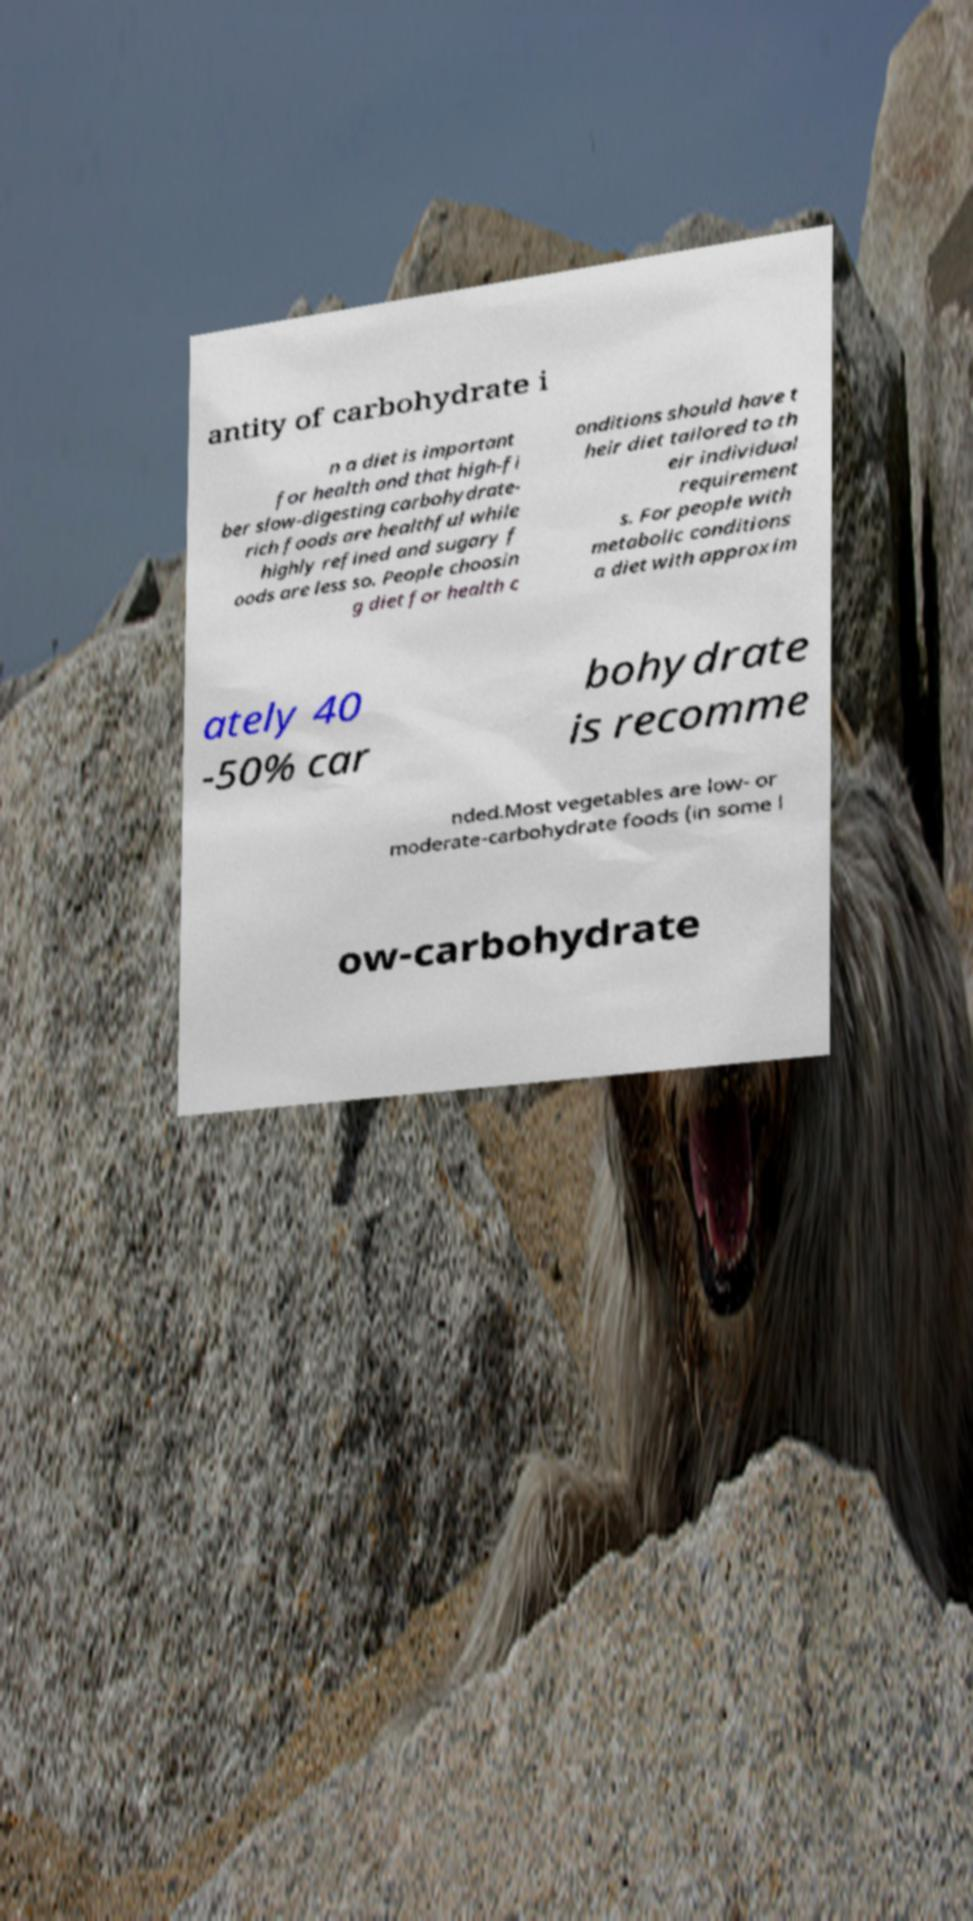I need the written content from this picture converted into text. Can you do that? antity of carbohydrate i n a diet is important for health and that high-fi ber slow-digesting carbohydrate- rich foods are healthful while highly refined and sugary f oods are less so. People choosin g diet for health c onditions should have t heir diet tailored to th eir individual requirement s. For people with metabolic conditions a diet with approxim ately 40 -50% car bohydrate is recomme nded.Most vegetables are low- or moderate-carbohydrate foods (in some l ow-carbohydrate 